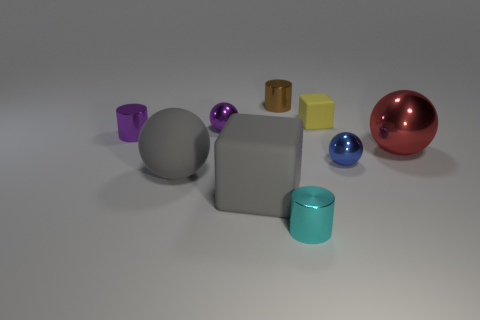Subtract all gray matte spheres. How many spheres are left? 3 Subtract all gray spheres. How many spheres are left? 3 Subtract all cubes. How many objects are left? 7 Subtract all red cylinders. Subtract all blue cubes. How many cylinders are left? 3 Subtract 1 blue spheres. How many objects are left? 8 Subtract all small yellow rubber cubes. Subtract all blue spheres. How many objects are left? 7 Add 5 gray spheres. How many gray spheres are left? 6 Add 1 big rubber things. How many big rubber things exist? 3 